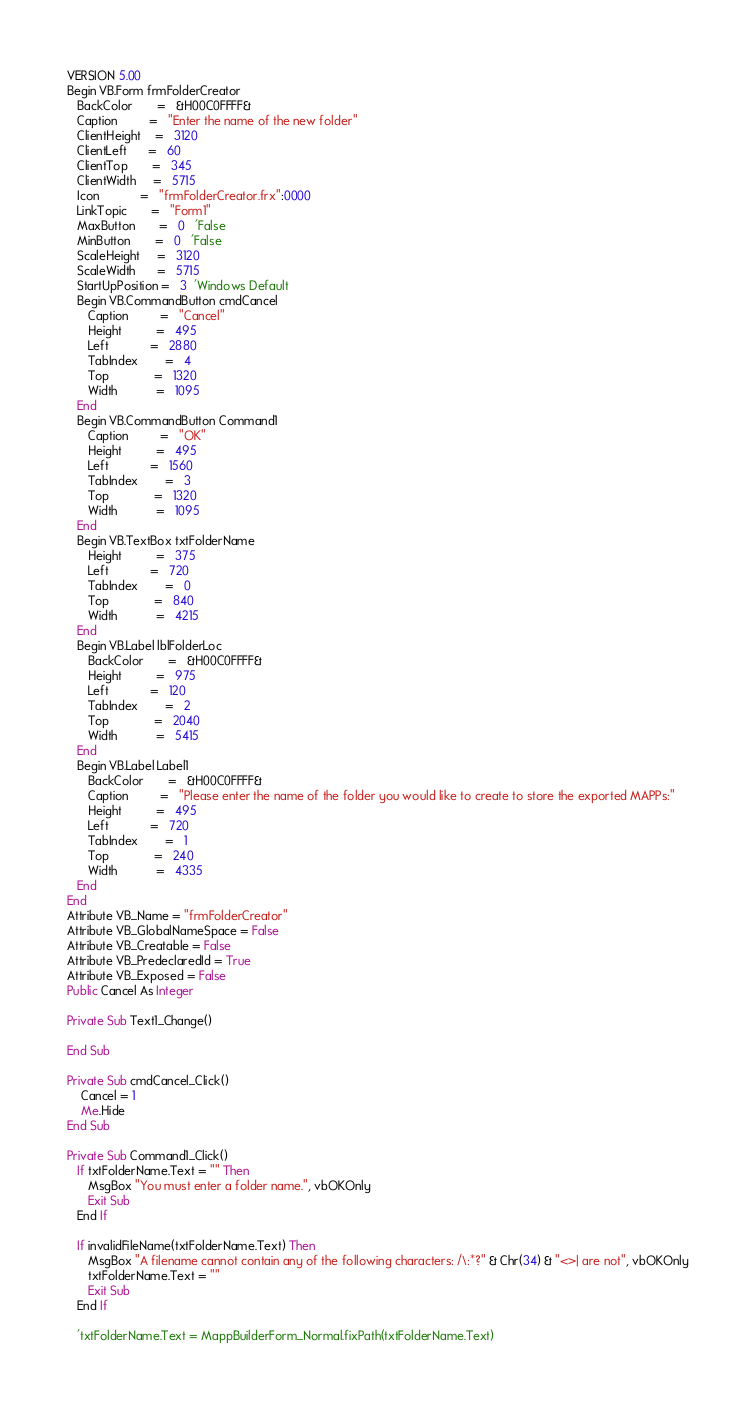<code> <loc_0><loc_0><loc_500><loc_500><_VisualBasic_>VERSION 5.00
Begin VB.Form frmFolderCreator 
   BackColor       =   &H00C0FFFF&
   Caption         =   "Enter the name of the new folder"
   ClientHeight    =   3120
   ClientLeft      =   60
   ClientTop       =   345
   ClientWidth     =   5715
   Icon            =   "frmFolderCreator.frx":0000
   LinkTopic       =   "Form1"
   MaxButton       =   0   'False
   MinButton       =   0   'False
   ScaleHeight     =   3120
   ScaleWidth      =   5715
   StartUpPosition =   3  'Windows Default
   Begin VB.CommandButton cmdCancel 
      Caption         =   "Cancel"
      Height          =   495
      Left            =   2880
      TabIndex        =   4
      Top             =   1320
      Width           =   1095
   End
   Begin VB.CommandButton Command1 
      Caption         =   "OK"
      Height          =   495
      Left            =   1560
      TabIndex        =   3
      Top             =   1320
      Width           =   1095
   End
   Begin VB.TextBox txtFolderName 
      Height          =   375
      Left            =   720
      TabIndex        =   0
      Top             =   840
      Width           =   4215
   End
   Begin VB.Label lblFolderLoc 
      BackColor       =   &H00C0FFFF&
      Height          =   975
      Left            =   120
      TabIndex        =   2
      Top             =   2040
      Width           =   5415
   End
   Begin VB.Label Label1 
      BackColor       =   &H00C0FFFF&
      Caption         =   "Please enter the name of the folder you would like to create to store the exported MAPPs:"
      Height          =   495
      Left            =   720
      TabIndex        =   1
      Top             =   240
      Width           =   4335
   End
End
Attribute VB_Name = "frmFolderCreator"
Attribute VB_GlobalNameSpace = False
Attribute VB_Creatable = False
Attribute VB_PredeclaredId = True
Attribute VB_Exposed = False
Public Cancel As Integer

Private Sub Text1_Change()

End Sub

Private Sub cmdCancel_Click()
    Cancel = 1
    Me.Hide
End Sub

Private Sub Command1_Click()
   If txtFolderName.Text = "" Then
      MsgBox "You must enter a folder name.", vbOKOnly
      Exit Sub
   End If
   
   If invalidFileName(txtFolderName.Text) Then
      MsgBox "A filename cannot contain any of the following characters: /\:*?" & Chr(34) & "<>| are not", vbOKOnly
      txtFolderName.Text = ""
      Exit Sub
   End If
   
   'txtFolderName.Text = MappBuilderForm_Normal.fixPath(txtFolderName.Text)
   </code> 